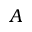<formula> <loc_0><loc_0><loc_500><loc_500>A</formula> 